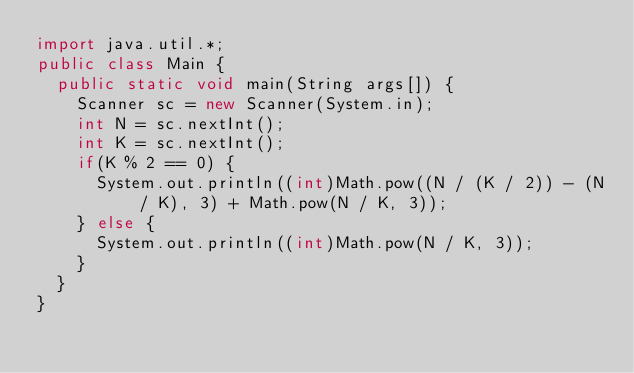Convert code to text. <code><loc_0><loc_0><loc_500><loc_500><_Java_>import java.util.*;
public class Main {
	public static void main(String args[]) {
		Scanner sc = new Scanner(System.in);
		int N = sc.nextInt();
		int K = sc.nextInt();
		if(K % 2 == 0) {
			System.out.println((int)Math.pow((N / (K / 2)) - (N / K), 3) + Math.pow(N / K, 3));
		} else {
			System.out.println((int)Math.pow(N / K, 3));
		}
	}
}
</code> 